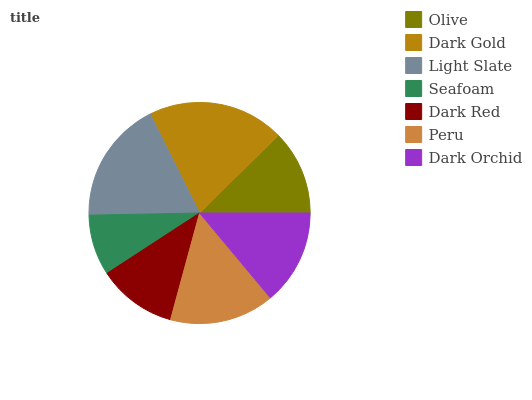Is Seafoam the minimum?
Answer yes or no. Yes. Is Dark Gold the maximum?
Answer yes or no. Yes. Is Light Slate the minimum?
Answer yes or no. No. Is Light Slate the maximum?
Answer yes or no. No. Is Dark Gold greater than Light Slate?
Answer yes or no. Yes. Is Light Slate less than Dark Gold?
Answer yes or no. Yes. Is Light Slate greater than Dark Gold?
Answer yes or no. No. Is Dark Gold less than Light Slate?
Answer yes or no. No. Is Dark Orchid the high median?
Answer yes or no. Yes. Is Dark Orchid the low median?
Answer yes or no. Yes. Is Seafoam the high median?
Answer yes or no. No. Is Olive the low median?
Answer yes or no. No. 